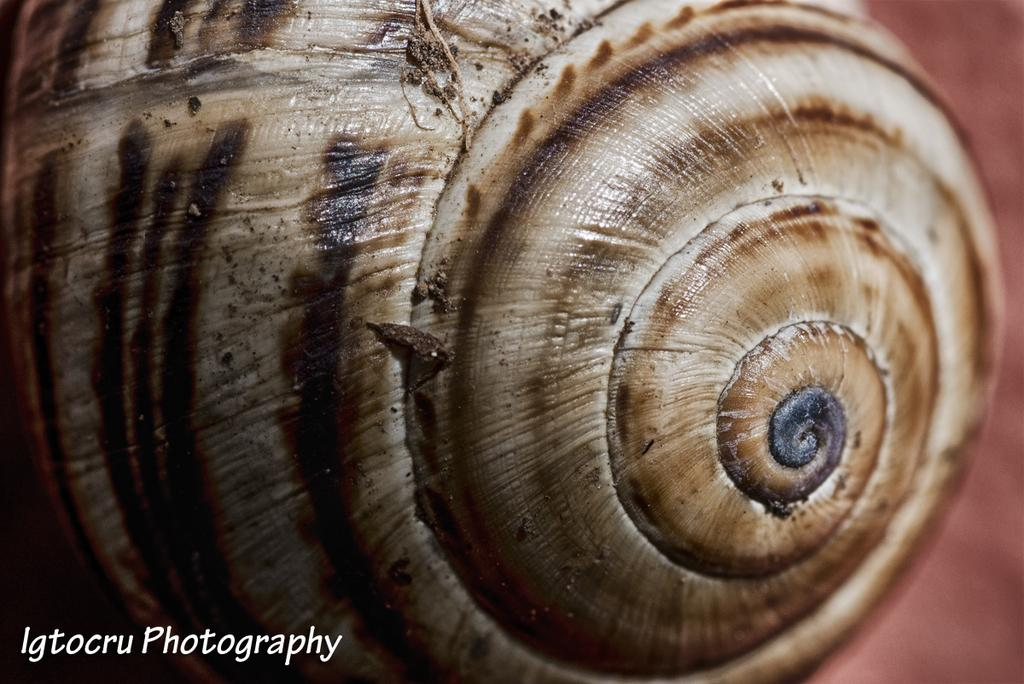What is the main subject in the foreground of the image? There is a seashell in the foreground of the image. What can be observed about the background of the image? The background of the image is colored. Is there any additional information or marking present in the image? Yes, there is a watermark in the bottom left corner of the image. How much money is being exchanged in the image? There is no money being exchanged in the image; it features a seashell and a colored background. Can you tell me where the nearest cemetery is located in the image? There is no cemetery present in the image; it features a seashell and a colored background. 